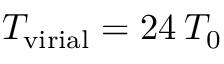Convert formula to latex. <formula><loc_0><loc_0><loc_500><loc_500>T _ { v i r i a l } = 2 4 \, T _ { 0 }</formula> 